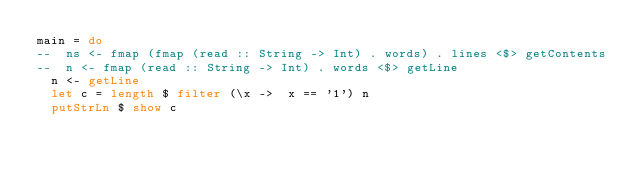<code> <loc_0><loc_0><loc_500><loc_500><_Haskell_>main = do
--  ns <- fmap (fmap (read :: String -> Int) . words) . lines <$> getContents
--  n <- fmap (read :: String -> Int) . words <$> getLine
  n <- getLine
  let c = length $ filter (\x ->  x == '1') n
  putStrLn $ show c</code> 